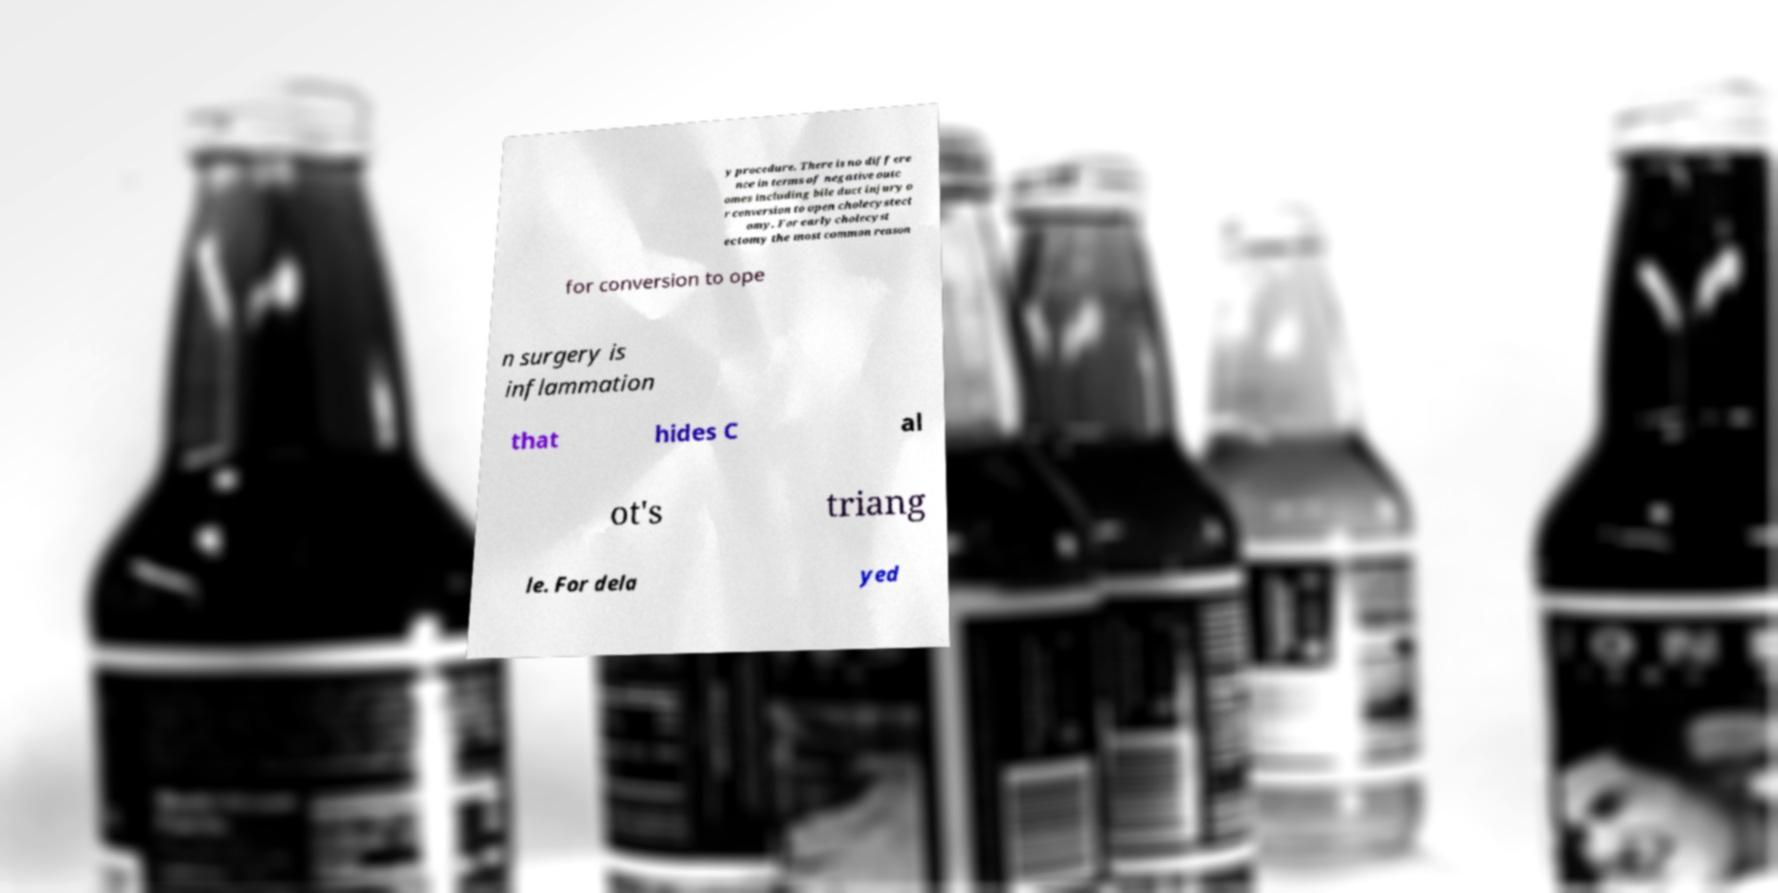For documentation purposes, I need the text within this image transcribed. Could you provide that? y procedure. There is no differe nce in terms of negative outc omes including bile duct injury o r conversion to open cholecystect omy. For early cholecyst ectomy the most common reason for conversion to ope n surgery is inflammation that hides C al ot's triang le. For dela yed 